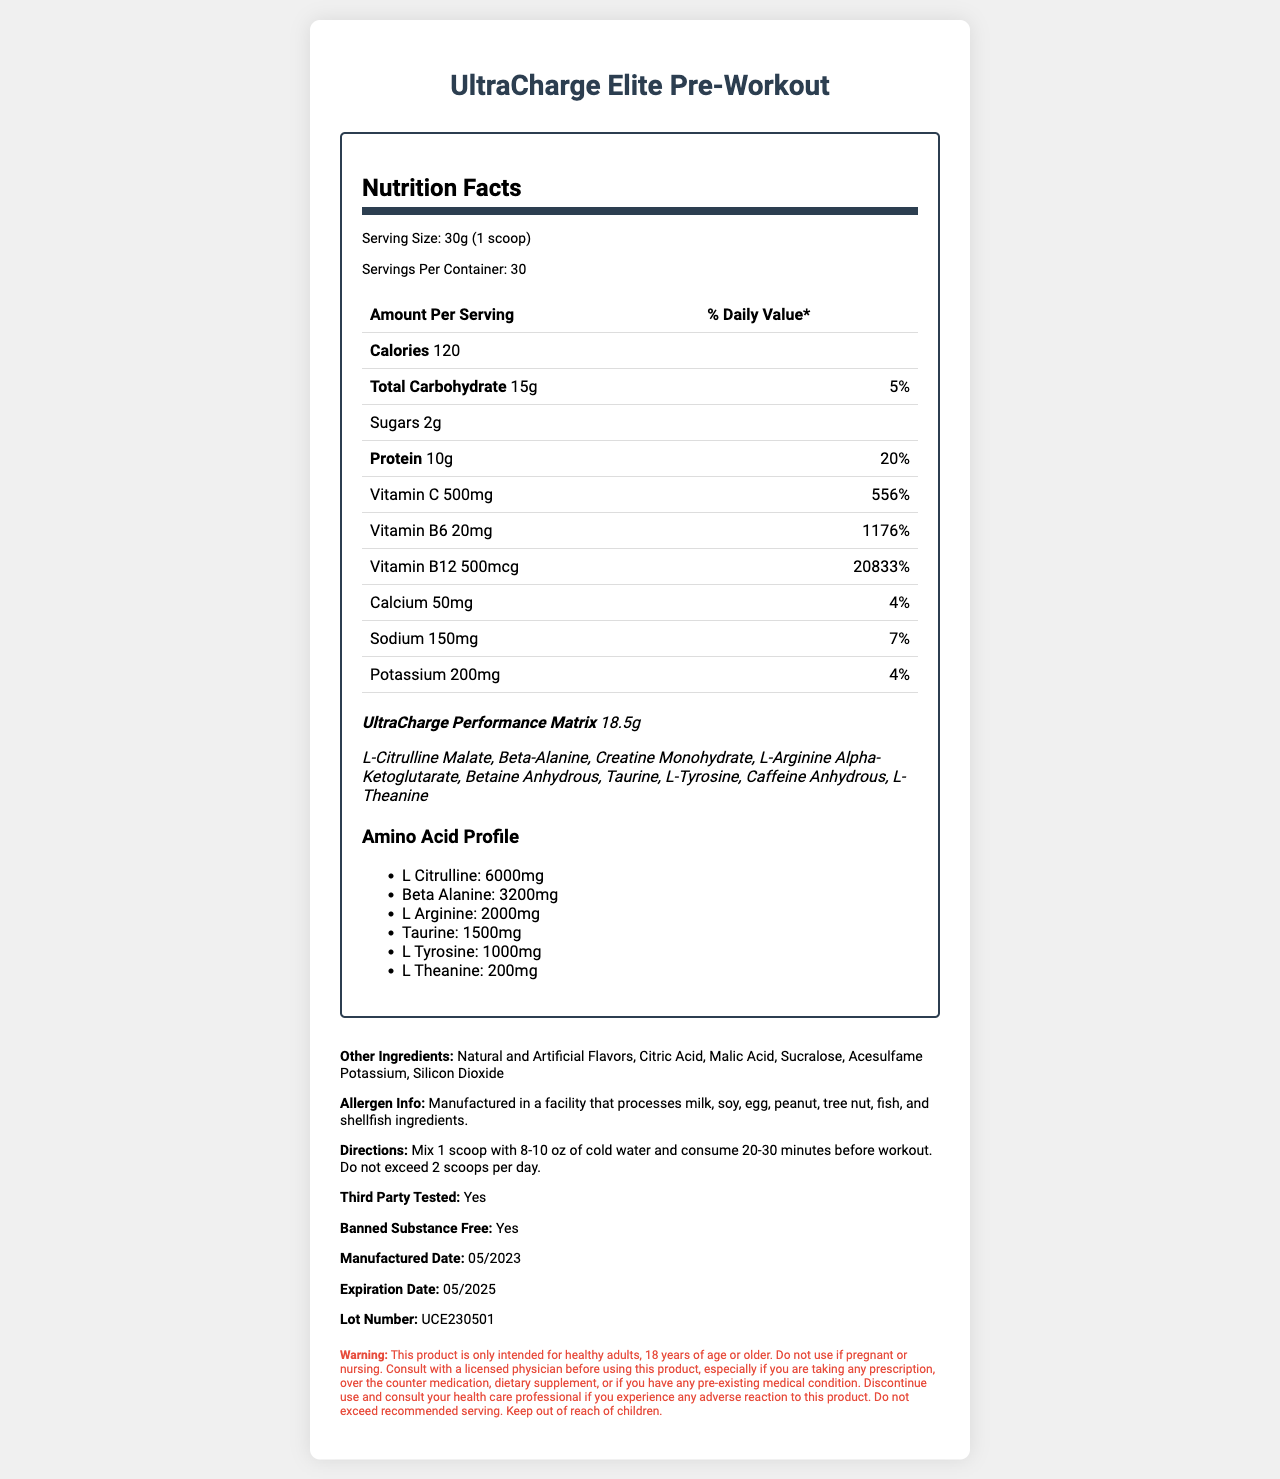how many calories are in one serving? The document specifies that one serving contains 120 calories.
Answer: 120 calories what is the serving size of UltraCharge Elite Pre-Workout? The serving size is clearly stated as 30g (1 scoop) in the document.
Answer: 30g (1 scoop) how much Vitamin C does one serving contain? The amount of Vitamin C per serving is listed as 500mg on the label.
Answer: 500mg is this product third-party tested? The document explicitly mentions that the product is third-party tested.
Answer: Yes which amino acid has the highest content listed in the profile? The amino acid profile lists L-Citrulline as having 6000mg, which is the highest amount among the amino acids listed.
Answer: L-Citrulline what percentage of the daily value for protein is provided by one serving? The daily value for protein provided by one serving is listed as 20%.
Answer: 20% is there any sugar in this product? The document states that each serving contains 2g of sugars.
Answer: Yes what are the first three ingredients in the UltraCharge Performance Matrix proprietary blend? These are the first three ingredients listed in the proprietary blend.
Answer: L-Citrulline Malate, Beta-Alanine, Creatine Monohydrate what is the expiration date of the product? The expiration date mentioned in the document is 05/2025.
Answer: 05/2025 how much caffeine anhydrous is listed in the amino acid profile? The amino acid profile does not list caffeine anhydrous.
Answer: Not listed which vitamins have daily values over 1000%? A. Vitamin C B. Vitamin B6 C. Vitamin B12 D. Calcium Both Vitamin B6 (1176%) and Vitamin B12 (20833%) have daily values over 1000%.
Answer: B and C what is the lot number of the product? A. UCE230501 B. UCE51502 C. UCE230502 D. UCE12345 The lot number specified in the document is UCE230501.
Answer: A is the product recommended for children? The document clearly states to keep the product out of reach of children and that it is intended only for healthy adults 18 years or older.
Answer: No summarize the main components and purpose of the UltraCharge Elite Pre-Workout product. The document provides a detailed outline of the product’s nutritional values, ingredients, and usage guidelines, indicating its design for improved workout performance.
Answer: The UltraCharge Elite Pre-Workout is a high-performance pre-workout powder designed to enhance workout performance. It offers a detailed nutrition label including 120 calories per serving, 10g of protein, a variety of vitamins and minerals, and an extensive amino acid profile. The product is third-party tested, banned substance free, and provides detailed consumption directions and warnings. what is the customer's feedback on this product? The document does not contain any information regarding customer feedback or reviews.
Answer: Cannot be determined 